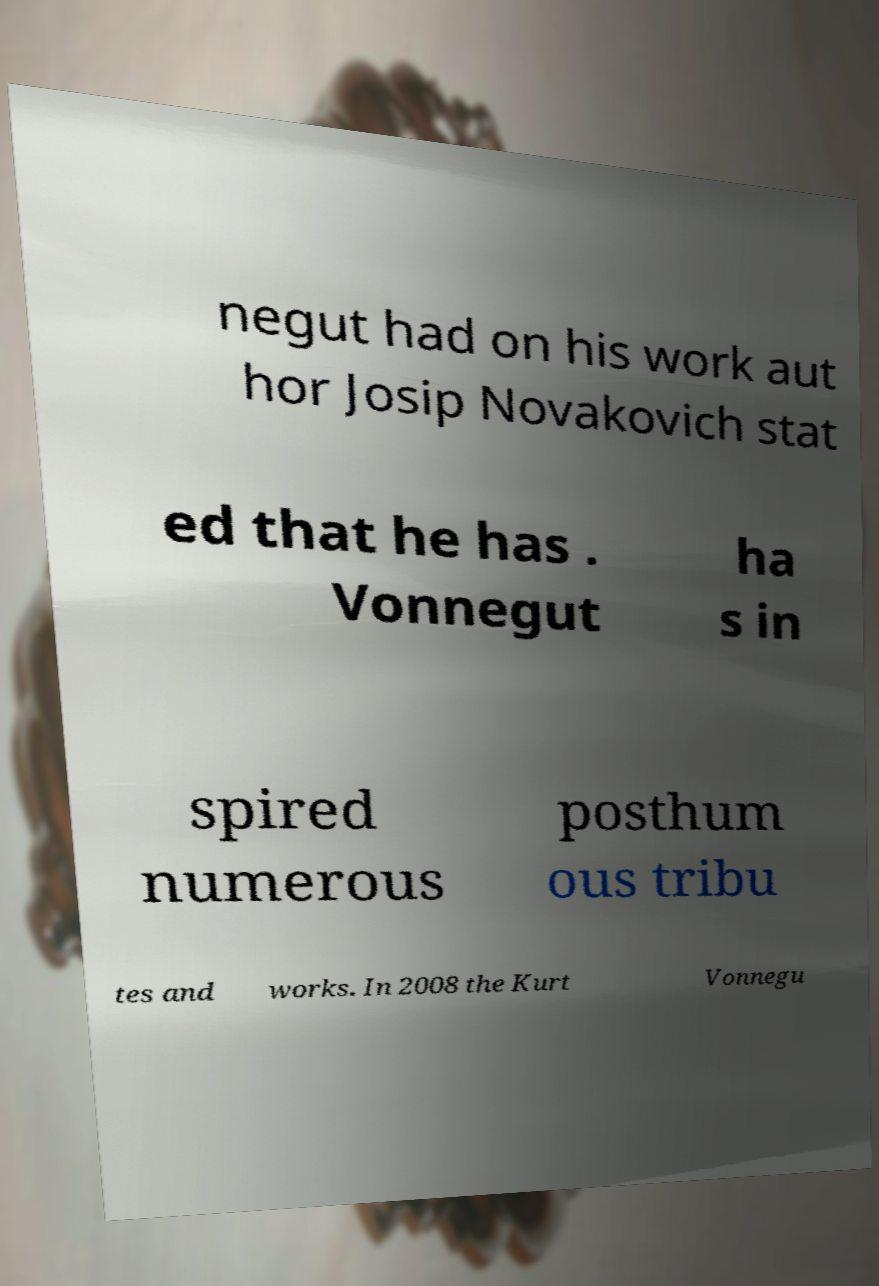For documentation purposes, I need the text within this image transcribed. Could you provide that? negut had on his work aut hor Josip Novakovich stat ed that he has . Vonnegut ha s in spired numerous posthum ous tribu tes and works. In 2008 the Kurt Vonnegu 